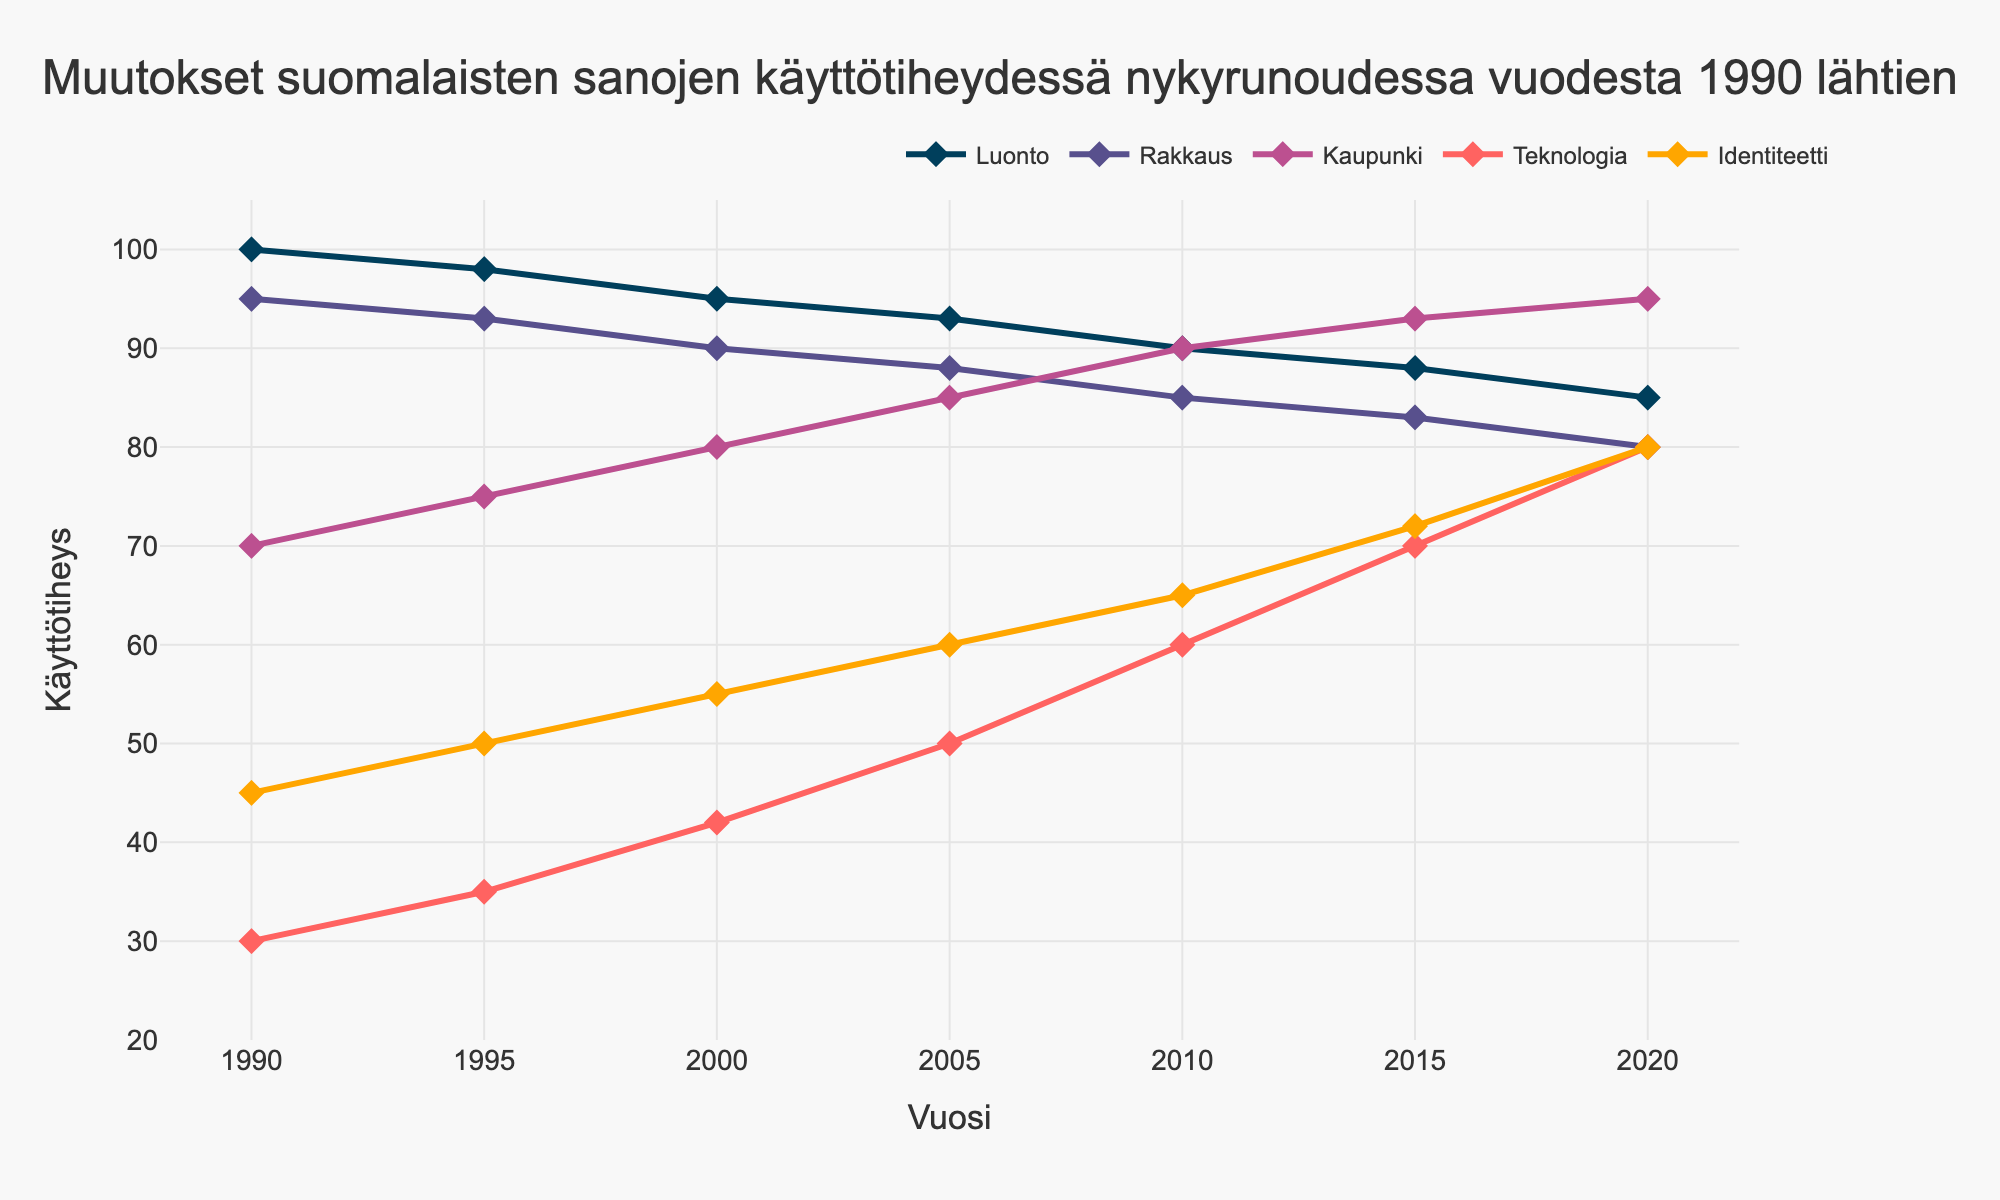What's the trend of the usage frequency for the word "Luonto" over time? To determine the trend, look at the data points associated with "Luonto" from 1990 to 2020. The values are decreasing over the years: 100 in 1990, 98 in 1995, 95 in 2000, 93 in 2005, 90 in 2010, 88 in 2015, and 85 in 2020.
Answer: Decreasing Which word had the highest usage frequency in 2020? To identify the word with the highest frequency in 2020, compare the values for all words in that year: Luonto (85), Rakkaus (80), Kaupunki (95), Teknologia (80), Identiteetti (80). "Kaupunki" has the highest value.
Answer: Kaupunki How did the usage of "Teknologia" change from 1990 to 2020? Examine the values for "Teknologia" in the years 1990 (30) and 2020 (80). The usage increased significantly. Calculate the difference: 80 - 30 = 50.
Answer: Increased by 50 Which word showed the most consistent trend over time from 1990 to 2020? Looking at the lines for each word, "Luonto" shows a steady decrease and thus seems the most consistent.
Answer: Luonto What is the overall trend for the word "Identiteetti" from 1990 to 2020 and what is its usage increase? Examine the usage of "Identiteetti" in 1990 (45) and 2020 (80), identifying an upward trend. The increase is 80 - 45 = 35.
Answer: Increasing, increased by 35 Between "Kaupunki" and "Rakkaus," which word had a higher usage frequency in 2005? Compare the values of "Kaupunki" (85) and "Rakkaus" (88) in 2005. "Rakkaus" is higher.
Answer: Rakkaus In which year did "Teknologia" surpass "Rakkaus" in usage frequency? Analyze the data points: "Teknologia" surpassed "Rakkaus" in 2010 (60 vs. 85), but the exact year this happened between 2005 and 2010.
Answer: 2010 What’s the average usage frequency of "Identiteetti" from 1990 to 2020? Sum the values and divide by the number of years: (45 + 50 + 55 + 60 + 65 + 72 + 80) / 7 = 427 / 7 = 61
Answer: 61 Compare the usage frequency changes between "Rakkaus" and "Luonto" from 1990 to 2020. Calculate differences: "Rakkaus" (95 to 80, a decrease of 15) and "Luonto" (100 to 85, a decrease of 15). Both decreased by 15.
Answer: Both decreased by 15 